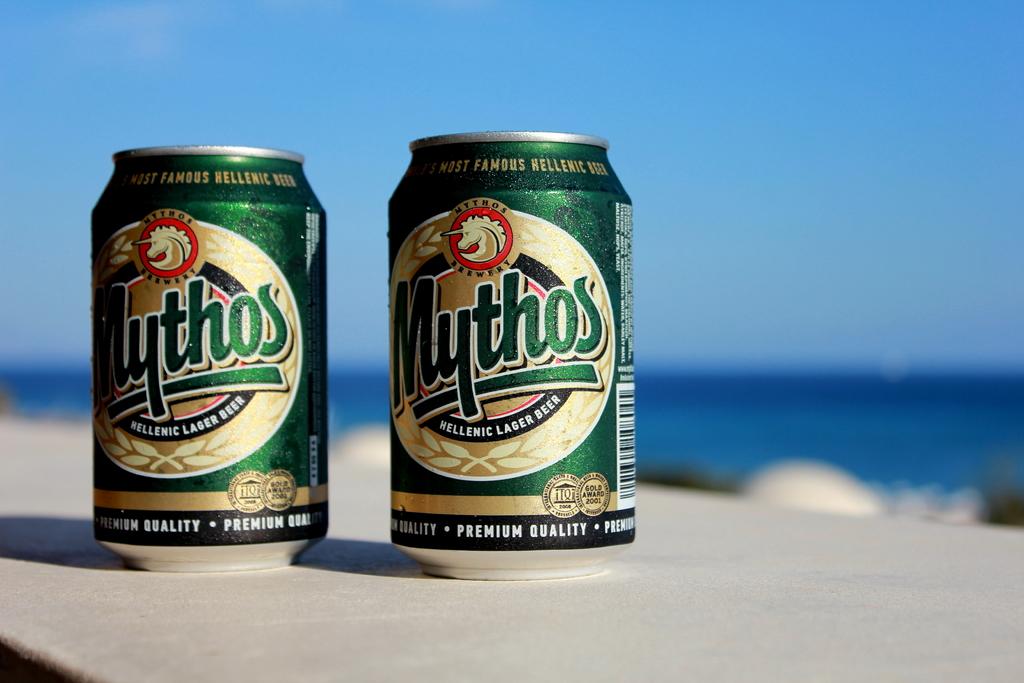What type of beer is in the can?
Provide a succinct answer. Mythos. What is the quality?
Offer a very short reply. Premium. 